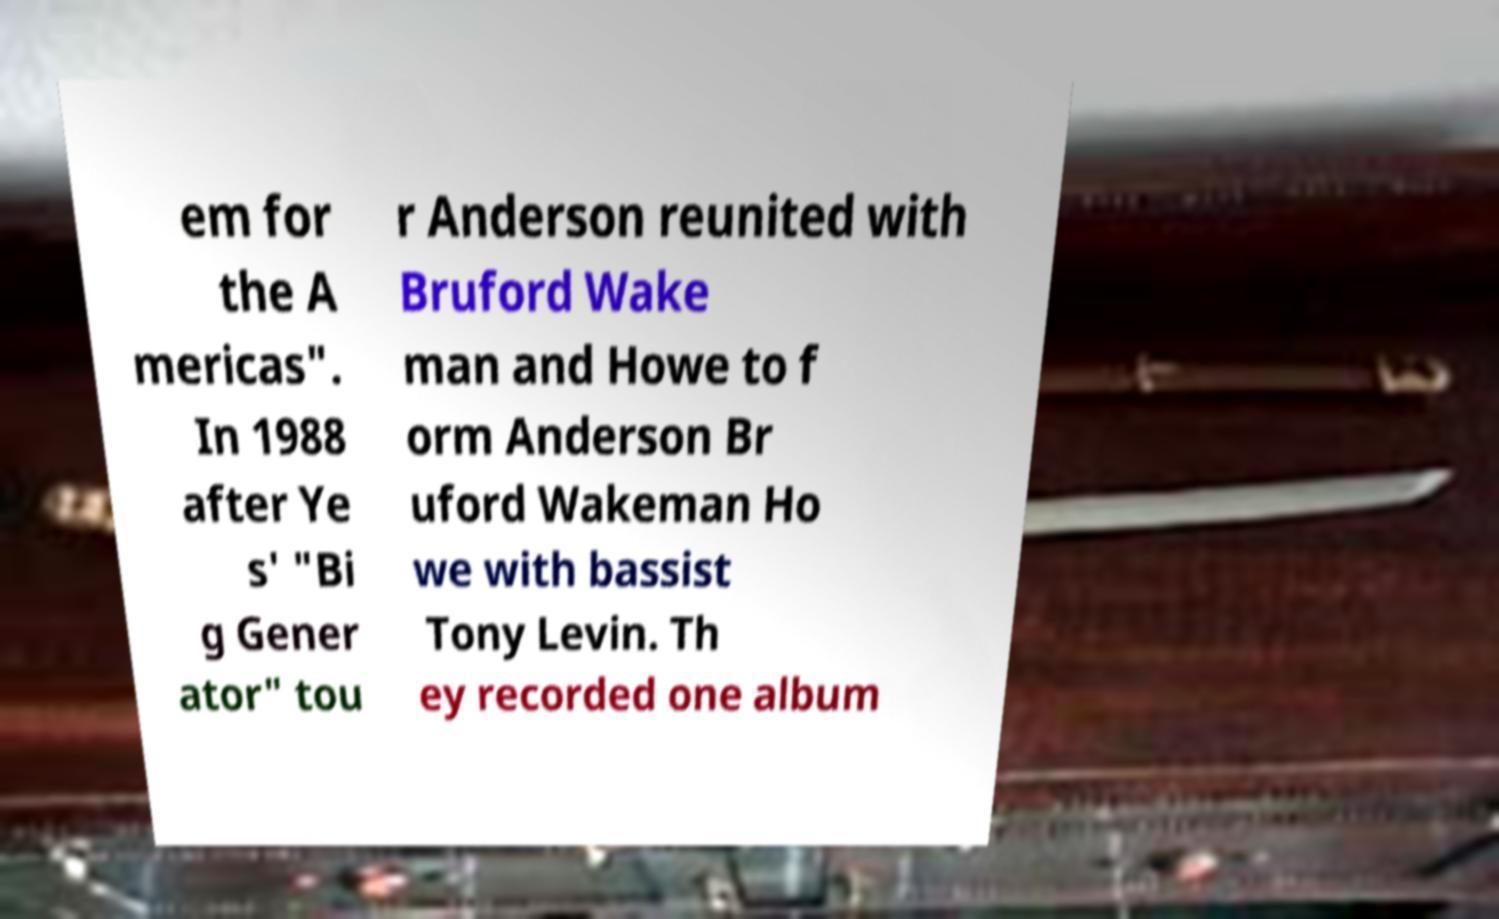Could you assist in decoding the text presented in this image and type it out clearly? em for the A mericas". In 1988 after Ye s' "Bi g Gener ator" tou r Anderson reunited with Bruford Wake man and Howe to f orm Anderson Br uford Wakeman Ho we with bassist Tony Levin. Th ey recorded one album 